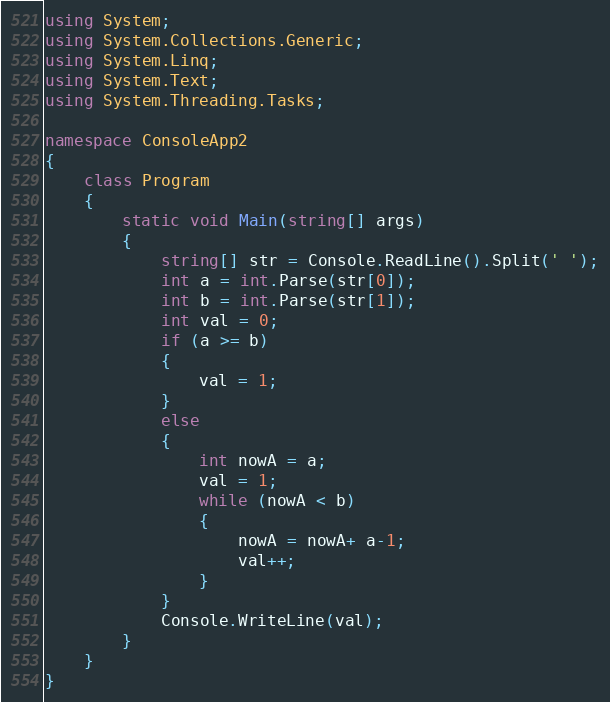Convert code to text. <code><loc_0><loc_0><loc_500><loc_500><_C#_>using System;
using System.Collections.Generic;
using System.Linq;
using System.Text;
using System.Threading.Tasks;

namespace ConsoleApp2
{
    class Program
    {
        static void Main(string[] args)
        {
            string[] str = Console.ReadLine().Split(' ');
            int a = int.Parse(str[0]);
            int b = int.Parse(str[1]);
            int val = 0;
            if (a >= b)
            {
                val = 1;
            }
            else
            {
                int nowA = a;
                val = 1;
                while (nowA < b)
                {
                    nowA = nowA+ a-1;
                    val++;
                }
            }
            Console.WriteLine(val);
        }
    }
}
</code> 